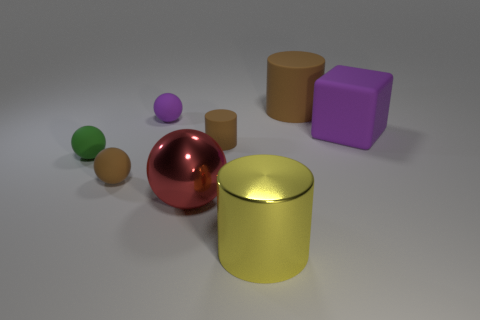Add 1 red rubber objects. How many objects exist? 9 Subtract all rubber cylinders. How many cylinders are left? 1 Subtract all cyan cubes. How many brown cylinders are left? 2 Subtract all red spheres. How many spheres are left? 3 Subtract all cubes. How many objects are left? 7 Subtract 2 cylinders. How many cylinders are left? 1 Subtract all yellow balls. Subtract all brown cylinders. How many balls are left? 4 Subtract all small green rubber balls. Subtract all purple matte objects. How many objects are left? 5 Add 6 red objects. How many red objects are left? 7 Add 3 large brown metallic objects. How many large brown metallic objects exist? 3 